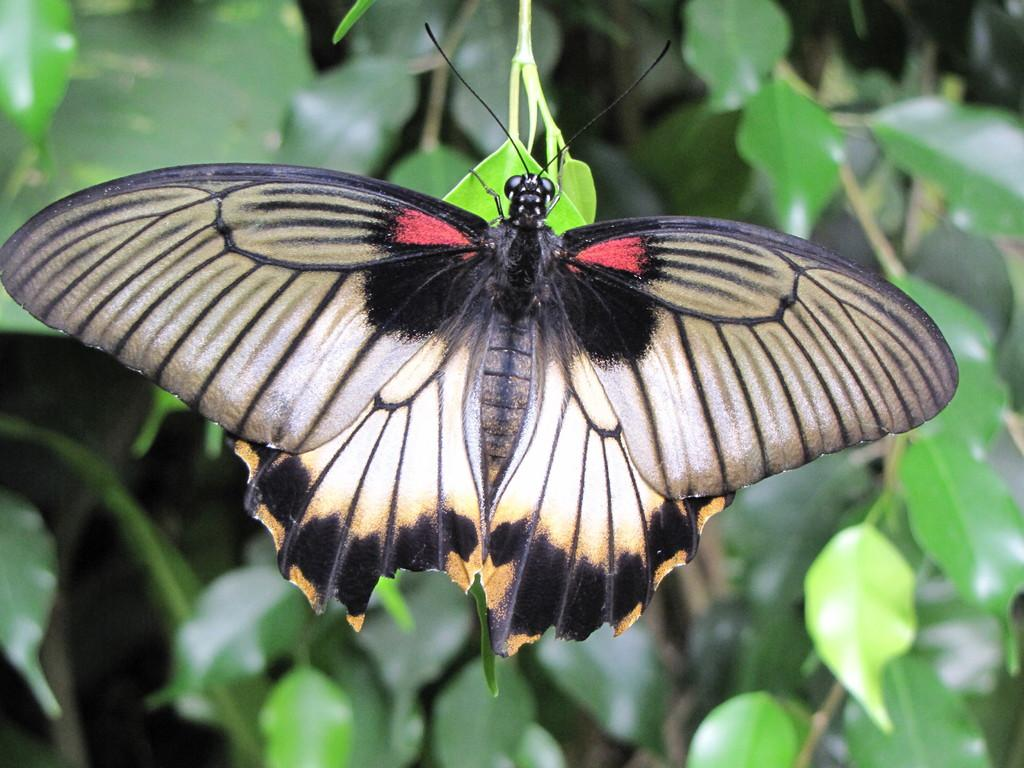What is the main subject of the image? There is a butterfly in the image. Where is the butterfly located in the image? The butterfly is in the front of the image. What can be seen in the background of the image? There are leaves in the background of the image. What type of ornament is hanging from the boat in the image? There is no boat or ornament present in the image; it features a butterfly in the front and leaves in the background. 